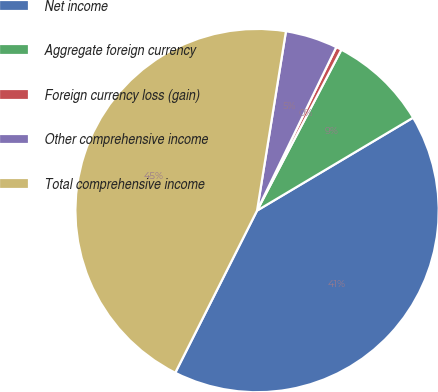Convert chart. <chart><loc_0><loc_0><loc_500><loc_500><pie_chart><fcel>Net income<fcel>Aggregate foreign currency<fcel>Foreign currency loss (gain)<fcel>Other comprehensive income<fcel>Total comprehensive income<nl><fcel>40.98%<fcel>8.77%<fcel>0.5%<fcel>4.64%<fcel>45.11%<nl></chart> 